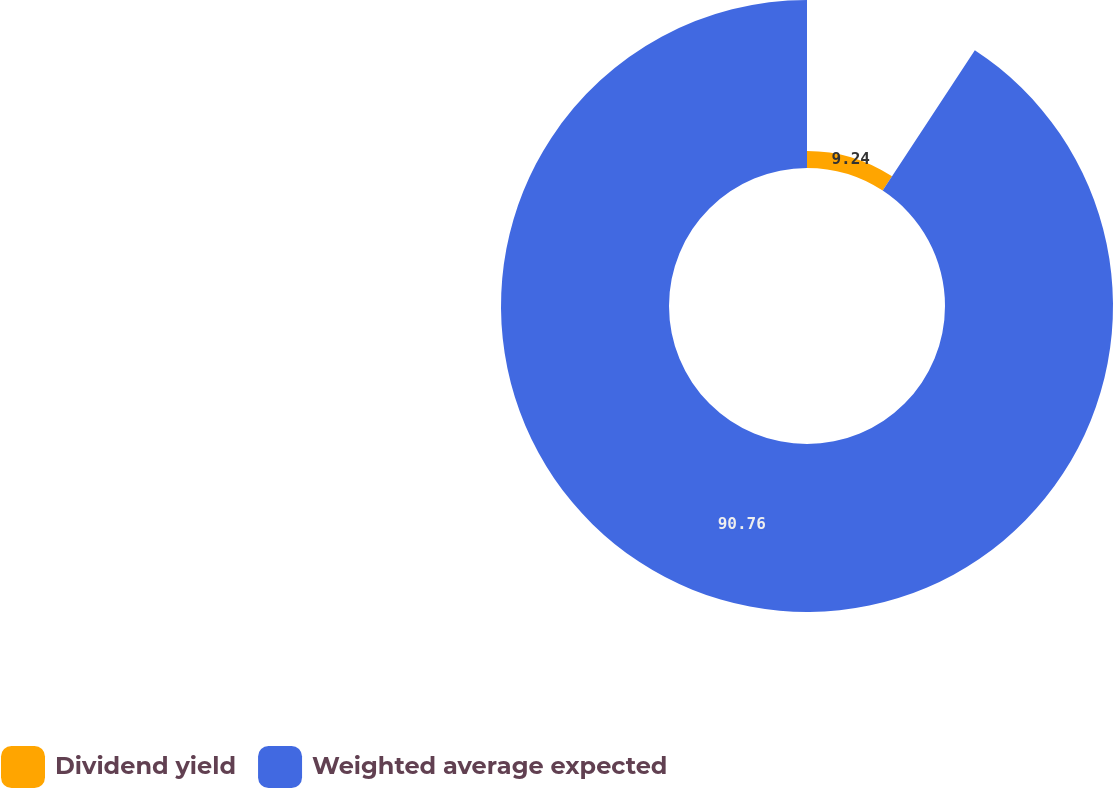<chart> <loc_0><loc_0><loc_500><loc_500><pie_chart><fcel>Dividend yield<fcel>Weighted average expected<nl><fcel>9.24%<fcel>90.76%<nl></chart> 